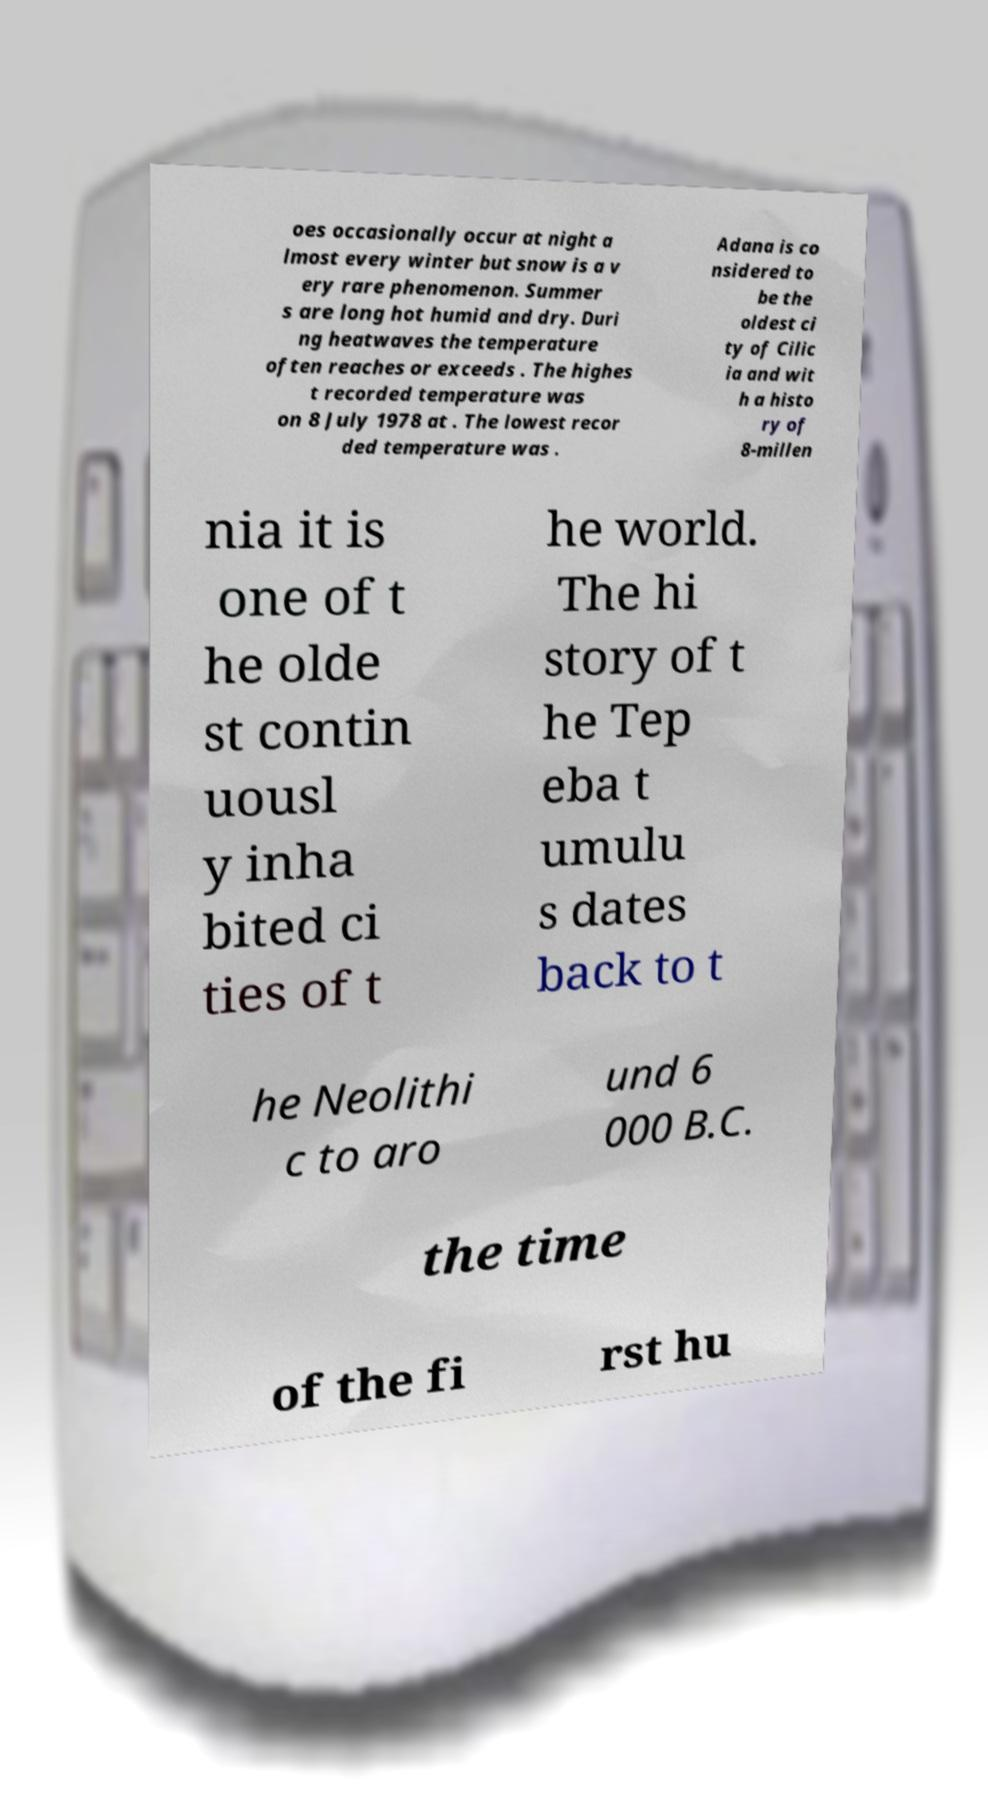Can you read and provide the text displayed in the image?This photo seems to have some interesting text. Can you extract and type it out for me? oes occasionally occur at night a lmost every winter but snow is a v ery rare phenomenon. Summer s are long hot humid and dry. Duri ng heatwaves the temperature often reaches or exceeds . The highes t recorded temperature was on 8 July 1978 at . The lowest recor ded temperature was . Adana is co nsidered to be the oldest ci ty of Cilic ia and wit h a histo ry of 8-millen nia it is one of t he olde st contin uousl y inha bited ci ties of t he world. The hi story of t he Tep eba t umulu s dates back to t he Neolithi c to aro und 6 000 B.C. the time of the fi rst hu 